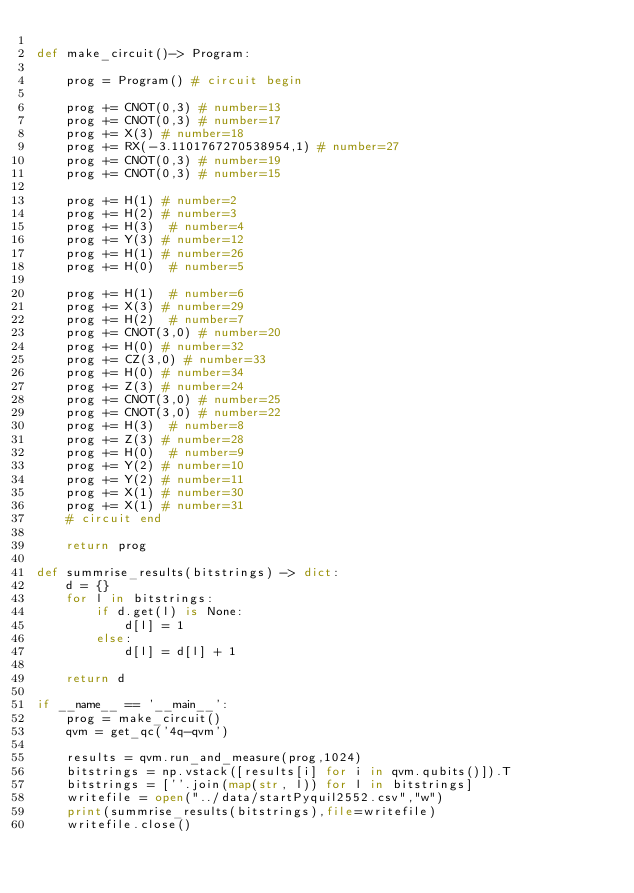Convert code to text. <code><loc_0><loc_0><loc_500><loc_500><_Python_>
def make_circuit()-> Program:

    prog = Program() # circuit begin

    prog += CNOT(0,3) # number=13
    prog += CNOT(0,3) # number=17
    prog += X(3) # number=18
    prog += RX(-3.1101767270538954,1) # number=27
    prog += CNOT(0,3) # number=19
    prog += CNOT(0,3) # number=15

    prog += H(1) # number=2
    prog += H(2) # number=3
    prog += H(3)  # number=4
    prog += Y(3) # number=12
    prog += H(1) # number=26
    prog += H(0)  # number=5

    prog += H(1)  # number=6
    prog += X(3) # number=29
    prog += H(2)  # number=7
    prog += CNOT(3,0) # number=20
    prog += H(0) # number=32
    prog += CZ(3,0) # number=33
    prog += H(0) # number=34
    prog += Z(3) # number=24
    prog += CNOT(3,0) # number=25
    prog += CNOT(3,0) # number=22
    prog += H(3)  # number=8
    prog += Z(3) # number=28
    prog += H(0)  # number=9
    prog += Y(2) # number=10
    prog += Y(2) # number=11
    prog += X(1) # number=30
    prog += X(1) # number=31
    # circuit end

    return prog

def summrise_results(bitstrings) -> dict:
    d = {}
    for l in bitstrings:
        if d.get(l) is None:
            d[l] = 1
        else:
            d[l] = d[l] + 1

    return d

if __name__ == '__main__':
    prog = make_circuit()
    qvm = get_qc('4q-qvm')

    results = qvm.run_and_measure(prog,1024)
    bitstrings = np.vstack([results[i] for i in qvm.qubits()]).T
    bitstrings = [''.join(map(str, l)) for l in bitstrings]
    writefile = open("../data/startPyquil2552.csv","w")
    print(summrise_results(bitstrings),file=writefile)
    writefile.close()

</code> 